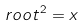<formula> <loc_0><loc_0><loc_500><loc_500>r o o t ^ { 2 } = x</formula> 